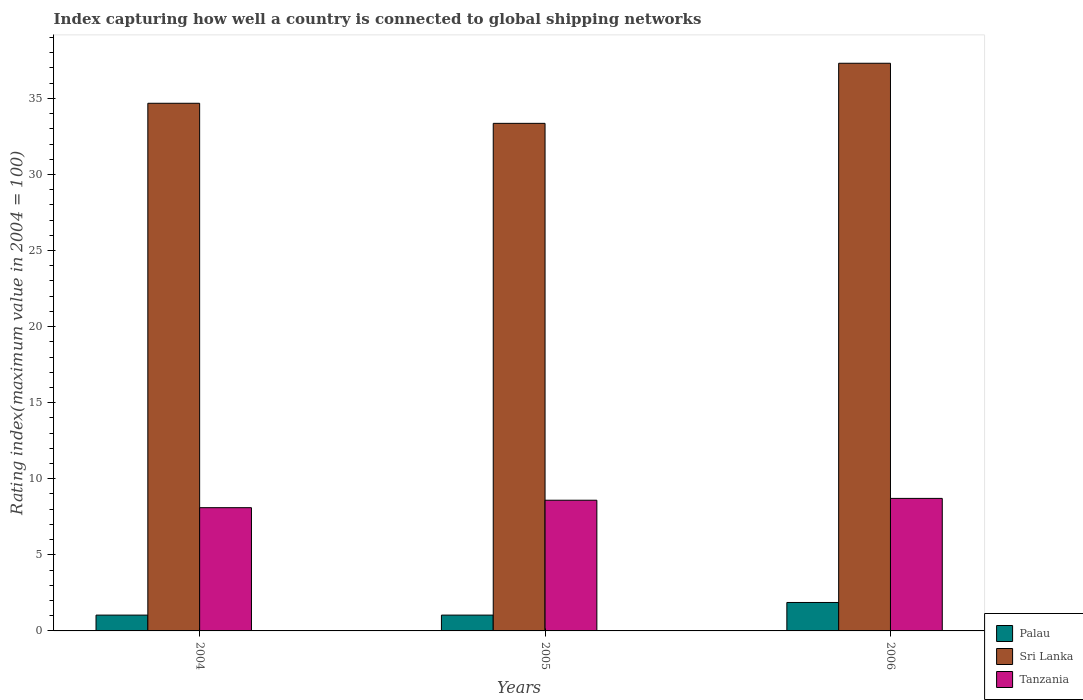Are the number of bars on each tick of the X-axis equal?
Give a very brief answer. Yes. How many bars are there on the 3rd tick from the left?
Provide a short and direct response. 3. What is the rating index in Sri Lanka in 2006?
Offer a terse response. 37.31. Across all years, what is the maximum rating index in Sri Lanka?
Your answer should be compact. 37.31. In which year was the rating index in Palau maximum?
Offer a terse response. 2006. In which year was the rating index in Sri Lanka minimum?
Offer a very short reply. 2005. What is the total rating index in Tanzania in the graph?
Keep it short and to the point. 25.4. What is the difference between the rating index in Tanzania in 2005 and that in 2006?
Provide a short and direct response. -0.12. What is the difference between the rating index in Sri Lanka in 2005 and the rating index in Palau in 2006?
Keep it short and to the point. 31.49. What is the average rating index in Tanzania per year?
Keep it short and to the point. 8.47. In the year 2004, what is the difference between the rating index in Tanzania and rating index in Sri Lanka?
Your response must be concise. -26.58. What is the ratio of the rating index in Sri Lanka in 2005 to that in 2006?
Your answer should be very brief. 0.89. Is the rating index in Sri Lanka in 2004 less than that in 2006?
Make the answer very short. Yes. What is the difference between the highest and the second highest rating index in Sri Lanka?
Give a very brief answer. 2.63. What is the difference between the highest and the lowest rating index in Sri Lanka?
Provide a short and direct response. 3.95. What does the 2nd bar from the left in 2006 represents?
Your response must be concise. Sri Lanka. What does the 2nd bar from the right in 2004 represents?
Offer a very short reply. Sri Lanka. How many bars are there?
Your response must be concise. 9. Are the values on the major ticks of Y-axis written in scientific E-notation?
Provide a short and direct response. No. Does the graph contain any zero values?
Give a very brief answer. No. Does the graph contain grids?
Offer a terse response. No. How many legend labels are there?
Your answer should be very brief. 3. How are the legend labels stacked?
Offer a terse response. Vertical. What is the title of the graph?
Give a very brief answer. Index capturing how well a country is connected to global shipping networks. Does "Jamaica" appear as one of the legend labels in the graph?
Provide a succinct answer. No. What is the label or title of the X-axis?
Your answer should be compact. Years. What is the label or title of the Y-axis?
Keep it short and to the point. Rating index(maximum value in 2004 = 100). What is the Rating index(maximum value in 2004 = 100) in Sri Lanka in 2004?
Ensure brevity in your answer.  34.68. What is the Rating index(maximum value in 2004 = 100) of Tanzania in 2004?
Provide a short and direct response. 8.1. What is the Rating index(maximum value in 2004 = 100) in Palau in 2005?
Keep it short and to the point. 1.04. What is the Rating index(maximum value in 2004 = 100) of Sri Lanka in 2005?
Give a very brief answer. 33.36. What is the Rating index(maximum value in 2004 = 100) of Tanzania in 2005?
Provide a succinct answer. 8.59. What is the Rating index(maximum value in 2004 = 100) of Palau in 2006?
Your answer should be very brief. 1.87. What is the Rating index(maximum value in 2004 = 100) in Sri Lanka in 2006?
Your response must be concise. 37.31. What is the Rating index(maximum value in 2004 = 100) of Tanzania in 2006?
Provide a succinct answer. 8.71. Across all years, what is the maximum Rating index(maximum value in 2004 = 100) in Palau?
Give a very brief answer. 1.87. Across all years, what is the maximum Rating index(maximum value in 2004 = 100) in Sri Lanka?
Keep it short and to the point. 37.31. Across all years, what is the maximum Rating index(maximum value in 2004 = 100) of Tanzania?
Your response must be concise. 8.71. Across all years, what is the minimum Rating index(maximum value in 2004 = 100) of Palau?
Keep it short and to the point. 1.04. Across all years, what is the minimum Rating index(maximum value in 2004 = 100) of Sri Lanka?
Your response must be concise. 33.36. Across all years, what is the minimum Rating index(maximum value in 2004 = 100) in Tanzania?
Your answer should be compact. 8.1. What is the total Rating index(maximum value in 2004 = 100) in Palau in the graph?
Give a very brief answer. 3.95. What is the total Rating index(maximum value in 2004 = 100) in Sri Lanka in the graph?
Provide a succinct answer. 105.35. What is the total Rating index(maximum value in 2004 = 100) in Tanzania in the graph?
Make the answer very short. 25.4. What is the difference between the Rating index(maximum value in 2004 = 100) of Sri Lanka in 2004 and that in 2005?
Offer a very short reply. 1.32. What is the difference between the Rating index(maximum value in 2004 = 100) in Tanzania in 2004 and that in 2005?
Provide a short and direct response. -0.49. What is the difference between the Rating index(maximum value in 2004 = 100) in Palau in 2004 and that in 2006?
Ensure brevity in your answer.  -0.83. What is the difference between the Rating index(maximum value in 2004 = 100) in Sri Lanka in 2004 and that in 2006?
Your response must be concise. -2.63. What is the difference between the Rating index(maximum value in 2004 = 100) of Tanzania in 2004 and that in 2006?
Provide a short and direct response. -0.61. What is the difference between the Rating index(maximum value in 2004 = 100) in Palau in 2005 and that in 2006?
Ensure brevity in your answer.  -0.83. What is the difference between the Rating index(maximum value in 2004 = 100) in Sri Lanka in 2005 and that in 2006?
Ensure brevity in your answer.  -3.95. What is the difference between the Rating index(maximum value in 2004 = 100) of Tanzania in 2005 and that in 2006?
Provide a succinct answer. -0.12. What is the difference between the Rating index(maximum value in 2004 = 100) in Palau in 2004 and the Rating index(maximum value in 2004 = 100) in Sri Lanka in 2005?
Provide a succinct answer. -32.32. What is the difference between the Rating index(maximum value in 2004 = 100) of Palau in 2004 and the Rating index(maximum value in 2004 = 100) of Tanzania in 2005?
Keep it short and to the point. -7.55. What is the difference between the Rating index(maximum value in 2004 = 100) in Sri Lanka in 2004 and the Rating index(maximum value in 2004 = 100) in Tanzania in 2005?
Your answer should be compact. 26.09. What is the difference between the Rating index(maximum value in 2004 = 100) of Palau in 2004 and the Rating index(maximum value in 2004 = 100) of Sri Lanka in 2006?
Your answer should be compact. -36.27. What is the difference between the Rating index(maximum value in 2004 = 100) in Palau in 2004 and the Rating index(maximum value in 2004 = 100) in Tanzania in 2006?
Make the answer very short. -7.67. What is the difference between the Rating index(maximum value in 2004 = 100) in Sri Lanka in 2004 and the Rating index(maximum value in 2004 = 100) in Tanzania in 2006?
Your answer should be very brief. 25.97. What is the difference between the Rating index(maximum value in 2004 = 100) of Palau in 2005 and the Rating index(maximum value in 2004 = 100) of Sri Lanka in 2006?
Offer a very short reply. -36.27. What is the difference between the Rating index(maximum value in 2004 = 100) of Palau in 2005 and the Rating index(maximum value in 2004 = 100) of Tanzania in 2006?
Provide a short and direct response. -7.67. What is the difference between the Rating index(maximum value in 2004 = 100) of Sri Lanka in 2005 and the Rating index(maximum value in 2004 = 100) of Tanzania in 2006?
Keep it short and to the point. 24.65. What is the average Rating index(maximum value in 2004 = 100) of Palau per year?
Give a very brief answer. 1.32. What is the average Rating index(maximum value in 2004 = 100) in Sri Lanka per year?
Provide a succinct answer. 35.12. What is the average Rating index(maximum value in 2004 = 100) in Tanzania per year?
Make the answer very short. 8.47. In the year 2004, what is the difference between the Rating index(maximum value in 2004 = 100) of Palau and Rating index(maximum value in 2004 = 100) of Sri Lanka?
Give a very brief answer. -33.64. In the year 2004, what is the difference between the Rating index(maximum value in 2004 = 100) in Palau and Rating index(maximum value in 2004 = 100) in Tanzania?
Make the answer very short. -7.06. In the year 2004, what is the difference between the Rating index(maximum value in 2004 = 100) of Sri Lanka and Rating index(maximum value in 2004 = 100) of Tanzania?
Offer a terse response. 26.58. In the year 2005, what is the difference between the Rating index(maximum value in 2004 = 100) in Palau and Rating index(maximum value in 2004 = 100) in Sri Lanka?
Make the answer very short. -32.32. In the year 2005, what is the difference between the Rating index(maximum value in 2004 = 100) of Palau and Rating index(maximum value in 2004 = 100) of Tanzania?
Provide a short and direct response. -7.55. In the year 2005, what is the difference between the Rating index(maximum value in 2004 = 100) in Sri Lanka and Rating index(maximum value in 2004 = 100) in Tanzania?
Provide a short and direct response. 24.77. In the year 2006, what is the difference between the Rating index(maximum value in 2004 = 100) of Palau and Rating index(maximum value in 2004 = 100) of Sri Lanka?
Make the answer very short. -35.44. In the year 2006, what is the difference between the Rating index(maximum value in 2004 = 100) of Palau and Rating index(maximum value in 2004 = 100) of Tanzania?
Offer a very short reply. -6.84. In the year 2006, what is the difference between the Rating index(maximum value in 2004 = 100) in Sri Lanka and Rating index(maximum value in 2004 = 100) in Tanzania?
Give a very brief answer. 28.6. What is the ratio of the Rating index(maximum value in 2004 = 100) in Sri Lanka in 2004 to that in 2005?
Offer a terse response. 1.04. What is the ratio of the Rating index(maximum value in 2004 = 100) in Tanzania in 2004 to that in 2005?
Your response must be concise. 0.94. What is the ratio of the Rating index(maximum value in 2004 = 100) of Palau in 2004 to that in 2006?
Make the answer very short. 0.56. What is the ratio of the Rating index(maximum value in 2004 = 100) of Sri Lanka in 2004 to that in 2006?
Provide a succinct answer. 0.93. What is the ratio of the Rating index(maximum value in 2004 = 100) of Palau in 2005 to that in 2006?
Provide a short and direct response. 0.56. What is the ratio of the Rating index(maximum value in 2004 = 100) in Sri Lanka in 2005 to that in 2006?
Keep it short and to the point. 0.89. What is the ratio of the Rating index(maximum value in 2004 = 100) of Tanzania in 2005 to that in 2006?
Ensure brevity in your answer.  0.99. What is the difference between the highest and the second highest Rating index(maximum value in 2004 = 100) of Palau?
Your answer should be compact. 0.83. What is the difference between the highest and the second highest Rating index(maximum value in 2004 = 100) of Sri Lanka?
Provide a short and direct response. 2.63. What is the difference between the highest and the second highest Rating index(maximum value in 2004 = 100) in Tanzania?
Give a very brief answer. 0.12. What is the difference between the highest and the lowest Rating index(maximum value in 2004 = 100) of Palau?
Provide a succinct answer. 0.83. What is the difference between the highest and the lowest Rating index(maximum value in 2004 = 100) of Sri Lanka?
Your answer should be very brief. 3.95. What is the difference between the highest and the lowest Rating index(maximum value in 2004 = 100) in Tanzania?
Your answer should be very brief. 0.61. 